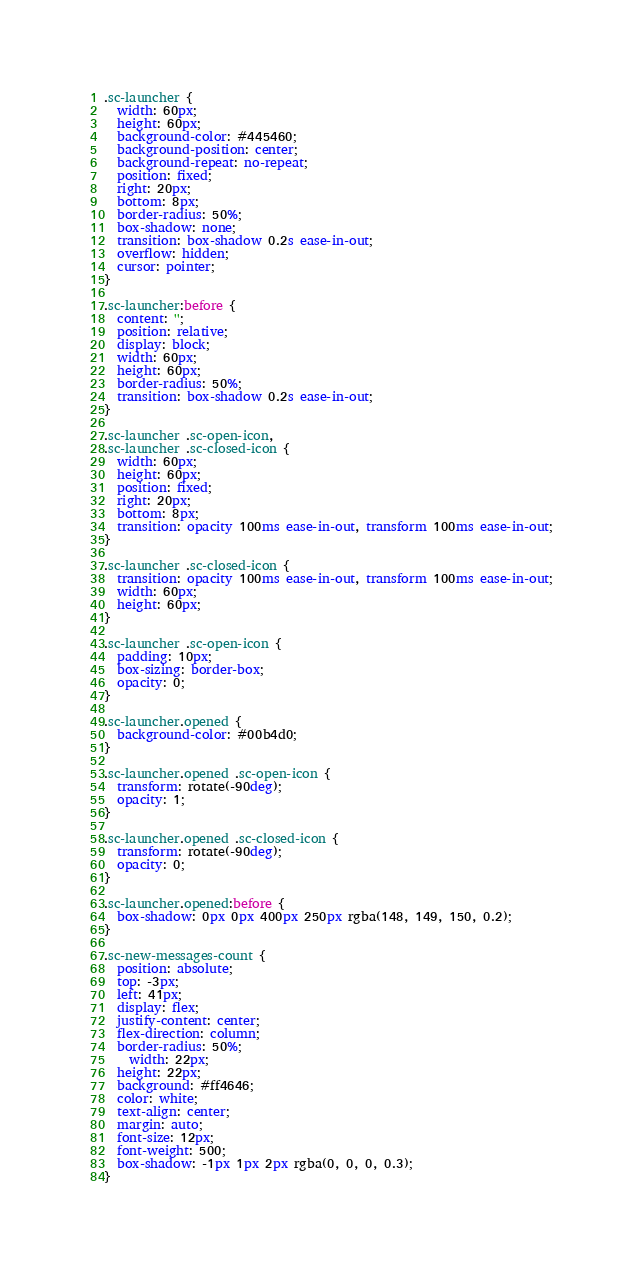<code> <loc_0><loc_0><loc_500><loc_500><_CSS_>.sc-launcher {
  width: 60px;
  height: 60px;
  background-color: #445460;
  background-position: center;
  background-repeat: no-repeat;
  position: fixed;
  right: 20px;
  bottom: 8px;
  border-radius: 50%;
  box-shadow: none;
  transition: box-shadow 0.2s ease-in-out;
  overflow: hidden;
  cursor: pointer;
}

.sc-launcher:before {
  content: '';
  position: relative;
  display: block;
  width: 60px;
  height: 60px;  
  border-radius: 50%;
  transition: box-shadow 0.2s ease-in-out;
}

.sc-launcher .sc-open-icon,
.sc-launcher .sc-closed-icon {
  width: 60px;
  height: 60px;
  position: fixed;
  right: 20px;
  bottom: 8px;
  transition: opacity 100ms ease-in-out, transform 100ms ease-in-out;
}

.sc-launcher .sc-closed-icon {
  transition: opacity 100ms ease-in-out, transform 100ms ease-in-out;
  width: 60px;
  height: 60px;
}

.sc-launcher .sc-open-icon {
  padding: 10px;
  box-sizing: border-box;
  opacity: 0;
}

.sc-launcher.opened {
  background-color: #00b4d0;
}

.sc-launcher.opened .sc-open-icon {
  transform: rotate(-90deg);
  opacity: 1;
}

.sc-launcher.opened .sc-closed-icon {
  transform: rotate(-90deg);
  opacity: 0;
}

.sc-launcher.opened:before {
  box-shadow: 0px 0px 400px 250px rgba(148, 149, 150, 0.2);
}

.sc-new-messages-count {
  position: absolute;
  top: -3px;
  left: 41px;
  display: flex;
  justify-content: center;
  flex-direction: column;
  border-radius: 50%;
	width: 22px;
  height: 22px;
  background: #ff4646;
  color: white;
  text-align: center;
  margin: auto;
  font-size: 12px;
  font-weight: 500;
  box-shadow: -1px 1px 2px rgba(0, 0, 0, 0.3);
}</code> 